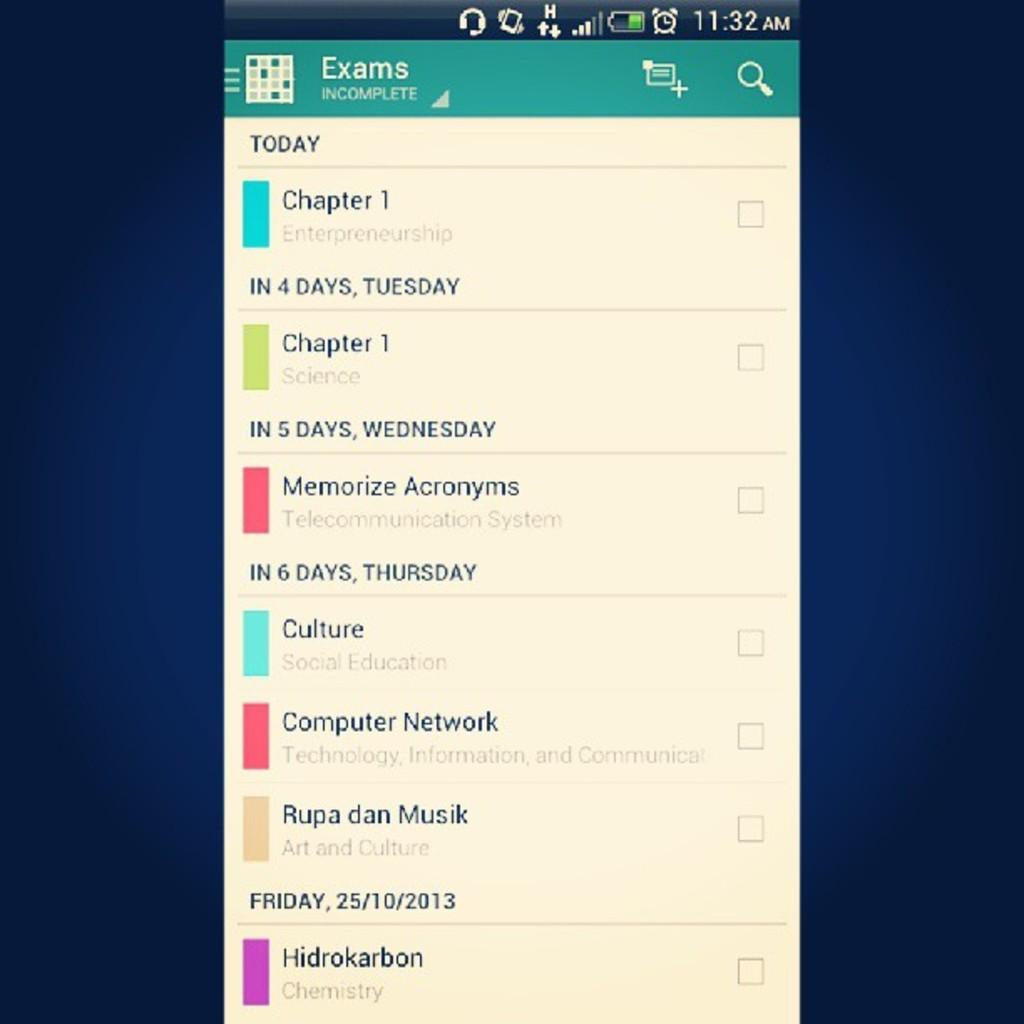Provide a one-sentence caption for the provided image. A calendar app that shows what exams are coming up. 